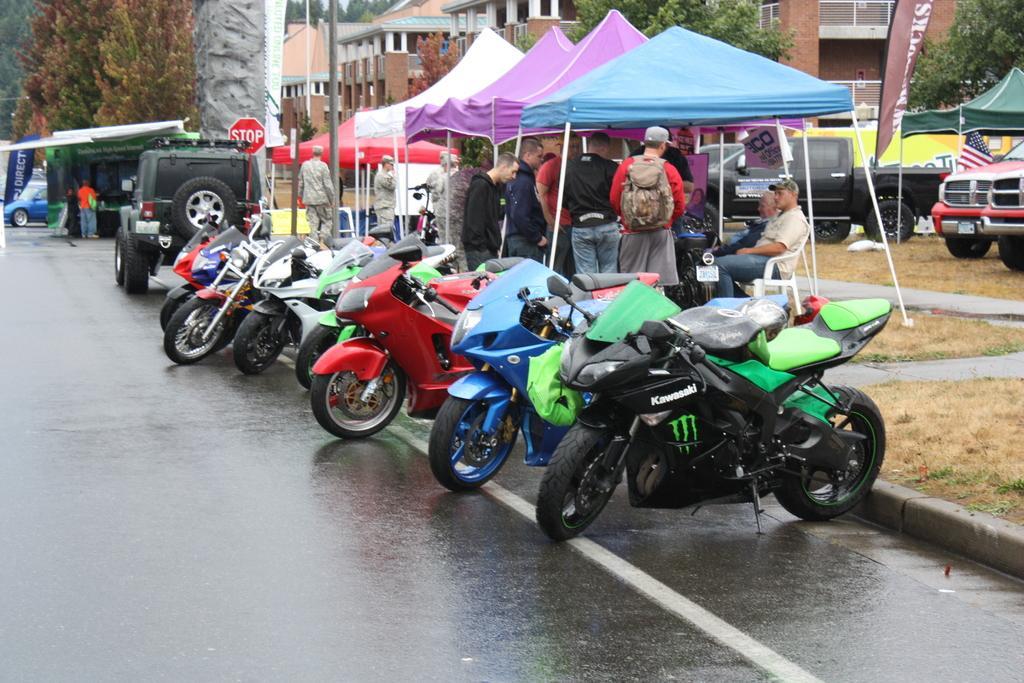Can you describe this image briefly? In this image, we can see some vehicles. There are persons and tents in the middle of the image. There are buildings and trees at the top of the image. 